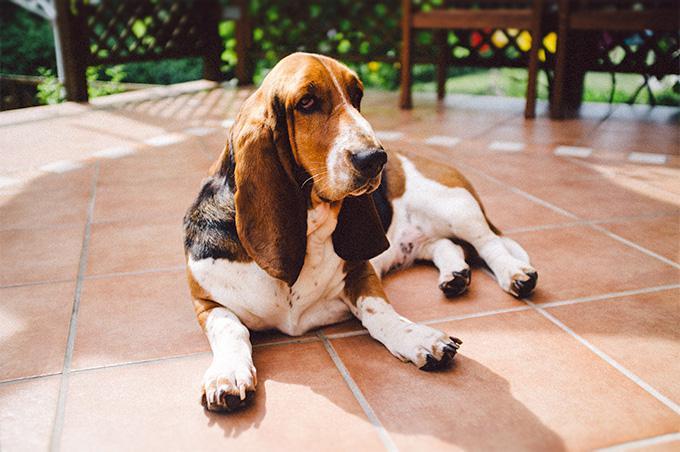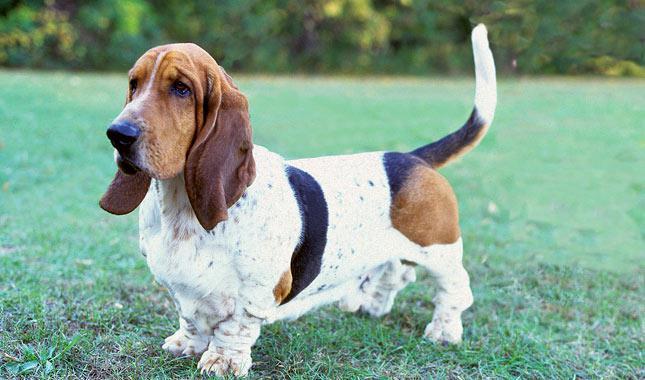The first image is the image on the left, the second image is the image on the right. Considering the images on both sides, is "bassett hounds are facing the camera" valid? Answer yes or no. No. The first image is the image on the left, the second image is the image on the right. Evaluate the accuracy of this statement regarding the images: "There is a single hound outside in the grass in the right image.". Is it true? Answer yes or no. Yes. 